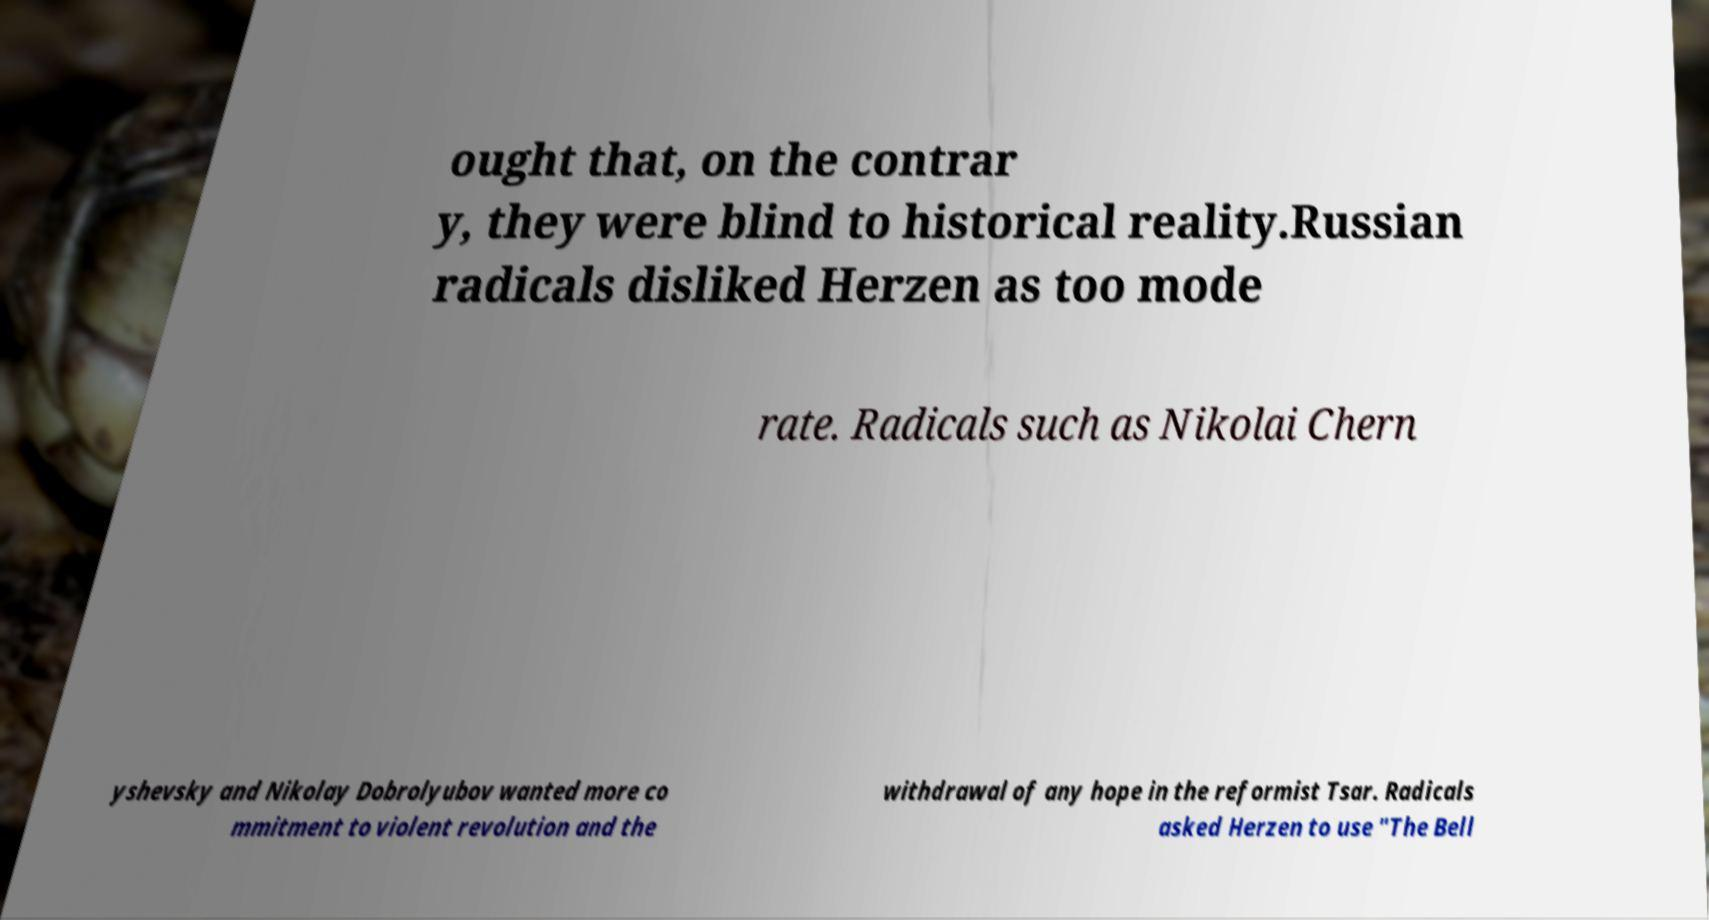There's text embedded in this image that I need extracted. Can you transcribe it verbatim? ought that, on the contrar y, they were blind to historical reality.Russian radicals disliked Herzen as too mode rate. Radicals such as Nikolai Chern yshevsky and Nikolay Dobrolyubov wanted more co mmitment to violent revolution and the withdrawal of any hope in the reformist Tsar. Radicals asked Herzen to use "The Bell 